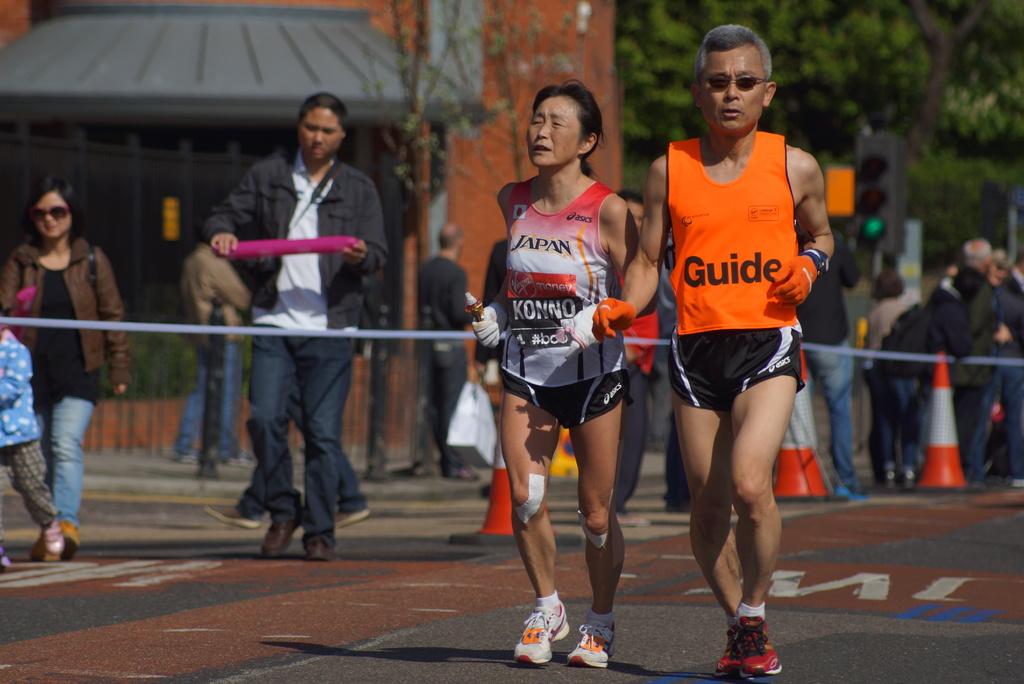What country is this woman likely from?
Provide a succinct answer. Japan. 